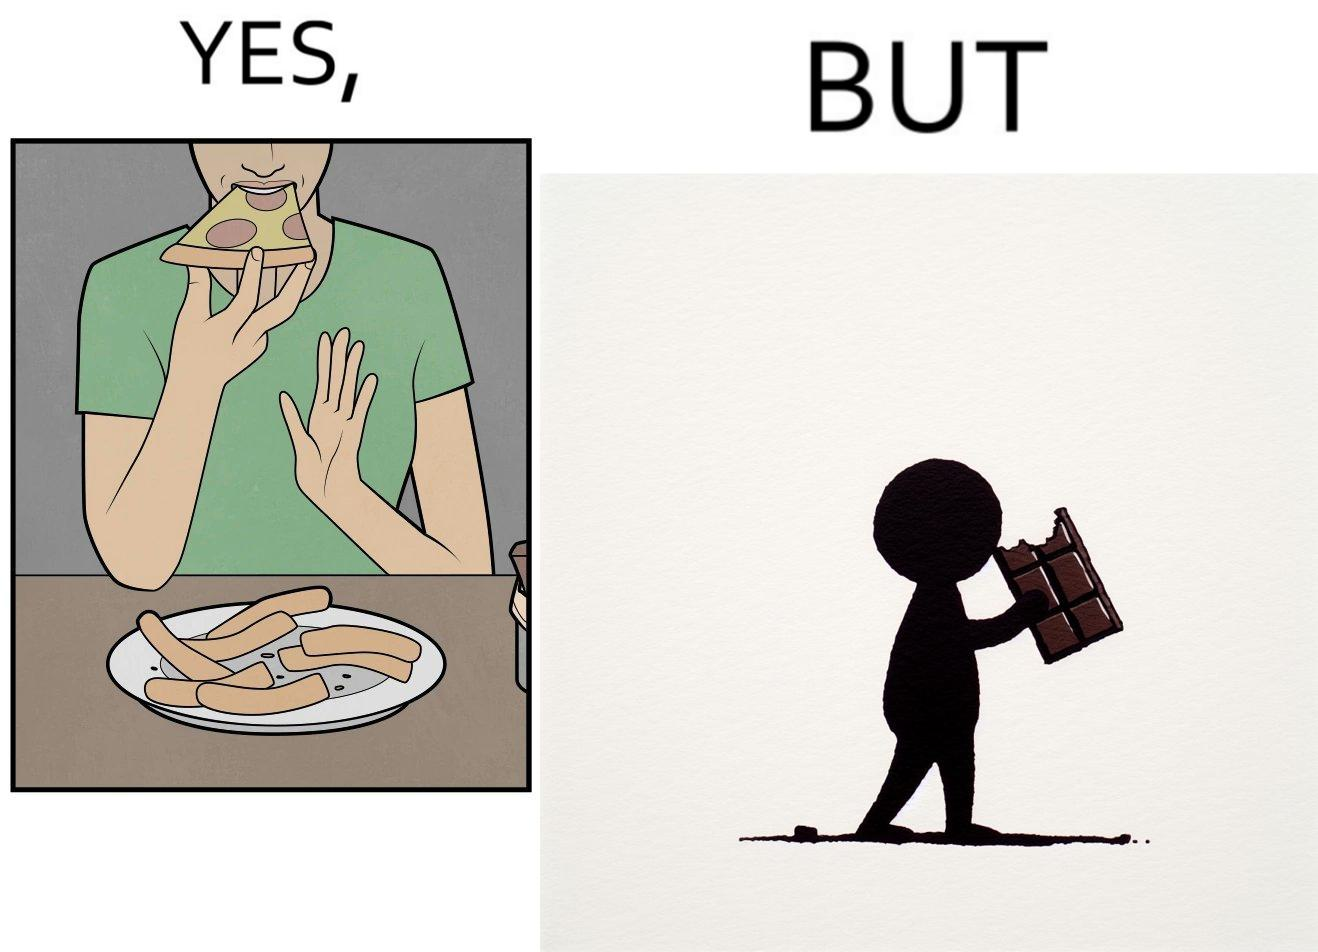Compare the left and right sides of this image. In the left part of the image: a person eating pizza and leaving the crusts on the table In the right part of the image: person eating chocolate bars 